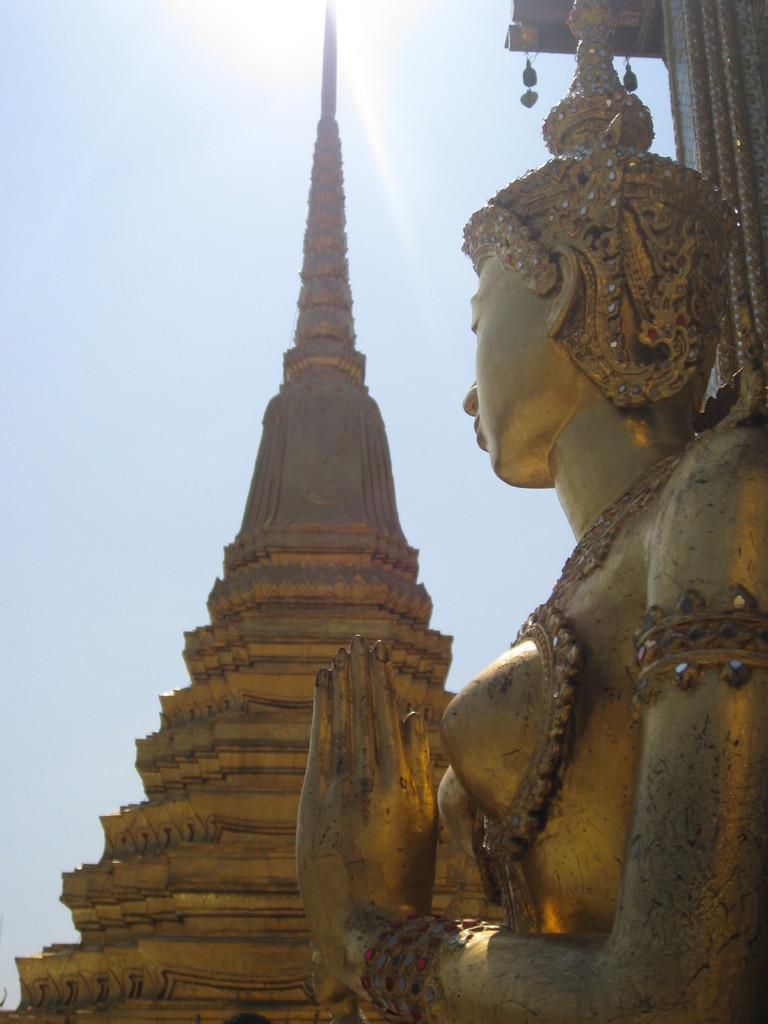What type of structure is present in the image? There is a building in the image. What artistic element can be seen in the image? There is a sculpture in the image. What is visible at the top of the image? The sky is visible at the top of the image. Can the sun be seen in the sky? Yes, the sun is observable in the sky. What type of trade is happening in the image? There is no indication of any trade in the image; it features a building, a sculpture, and a sky with the sun visible. Who is controlling the cart in the image? There is no cart present in the image. 